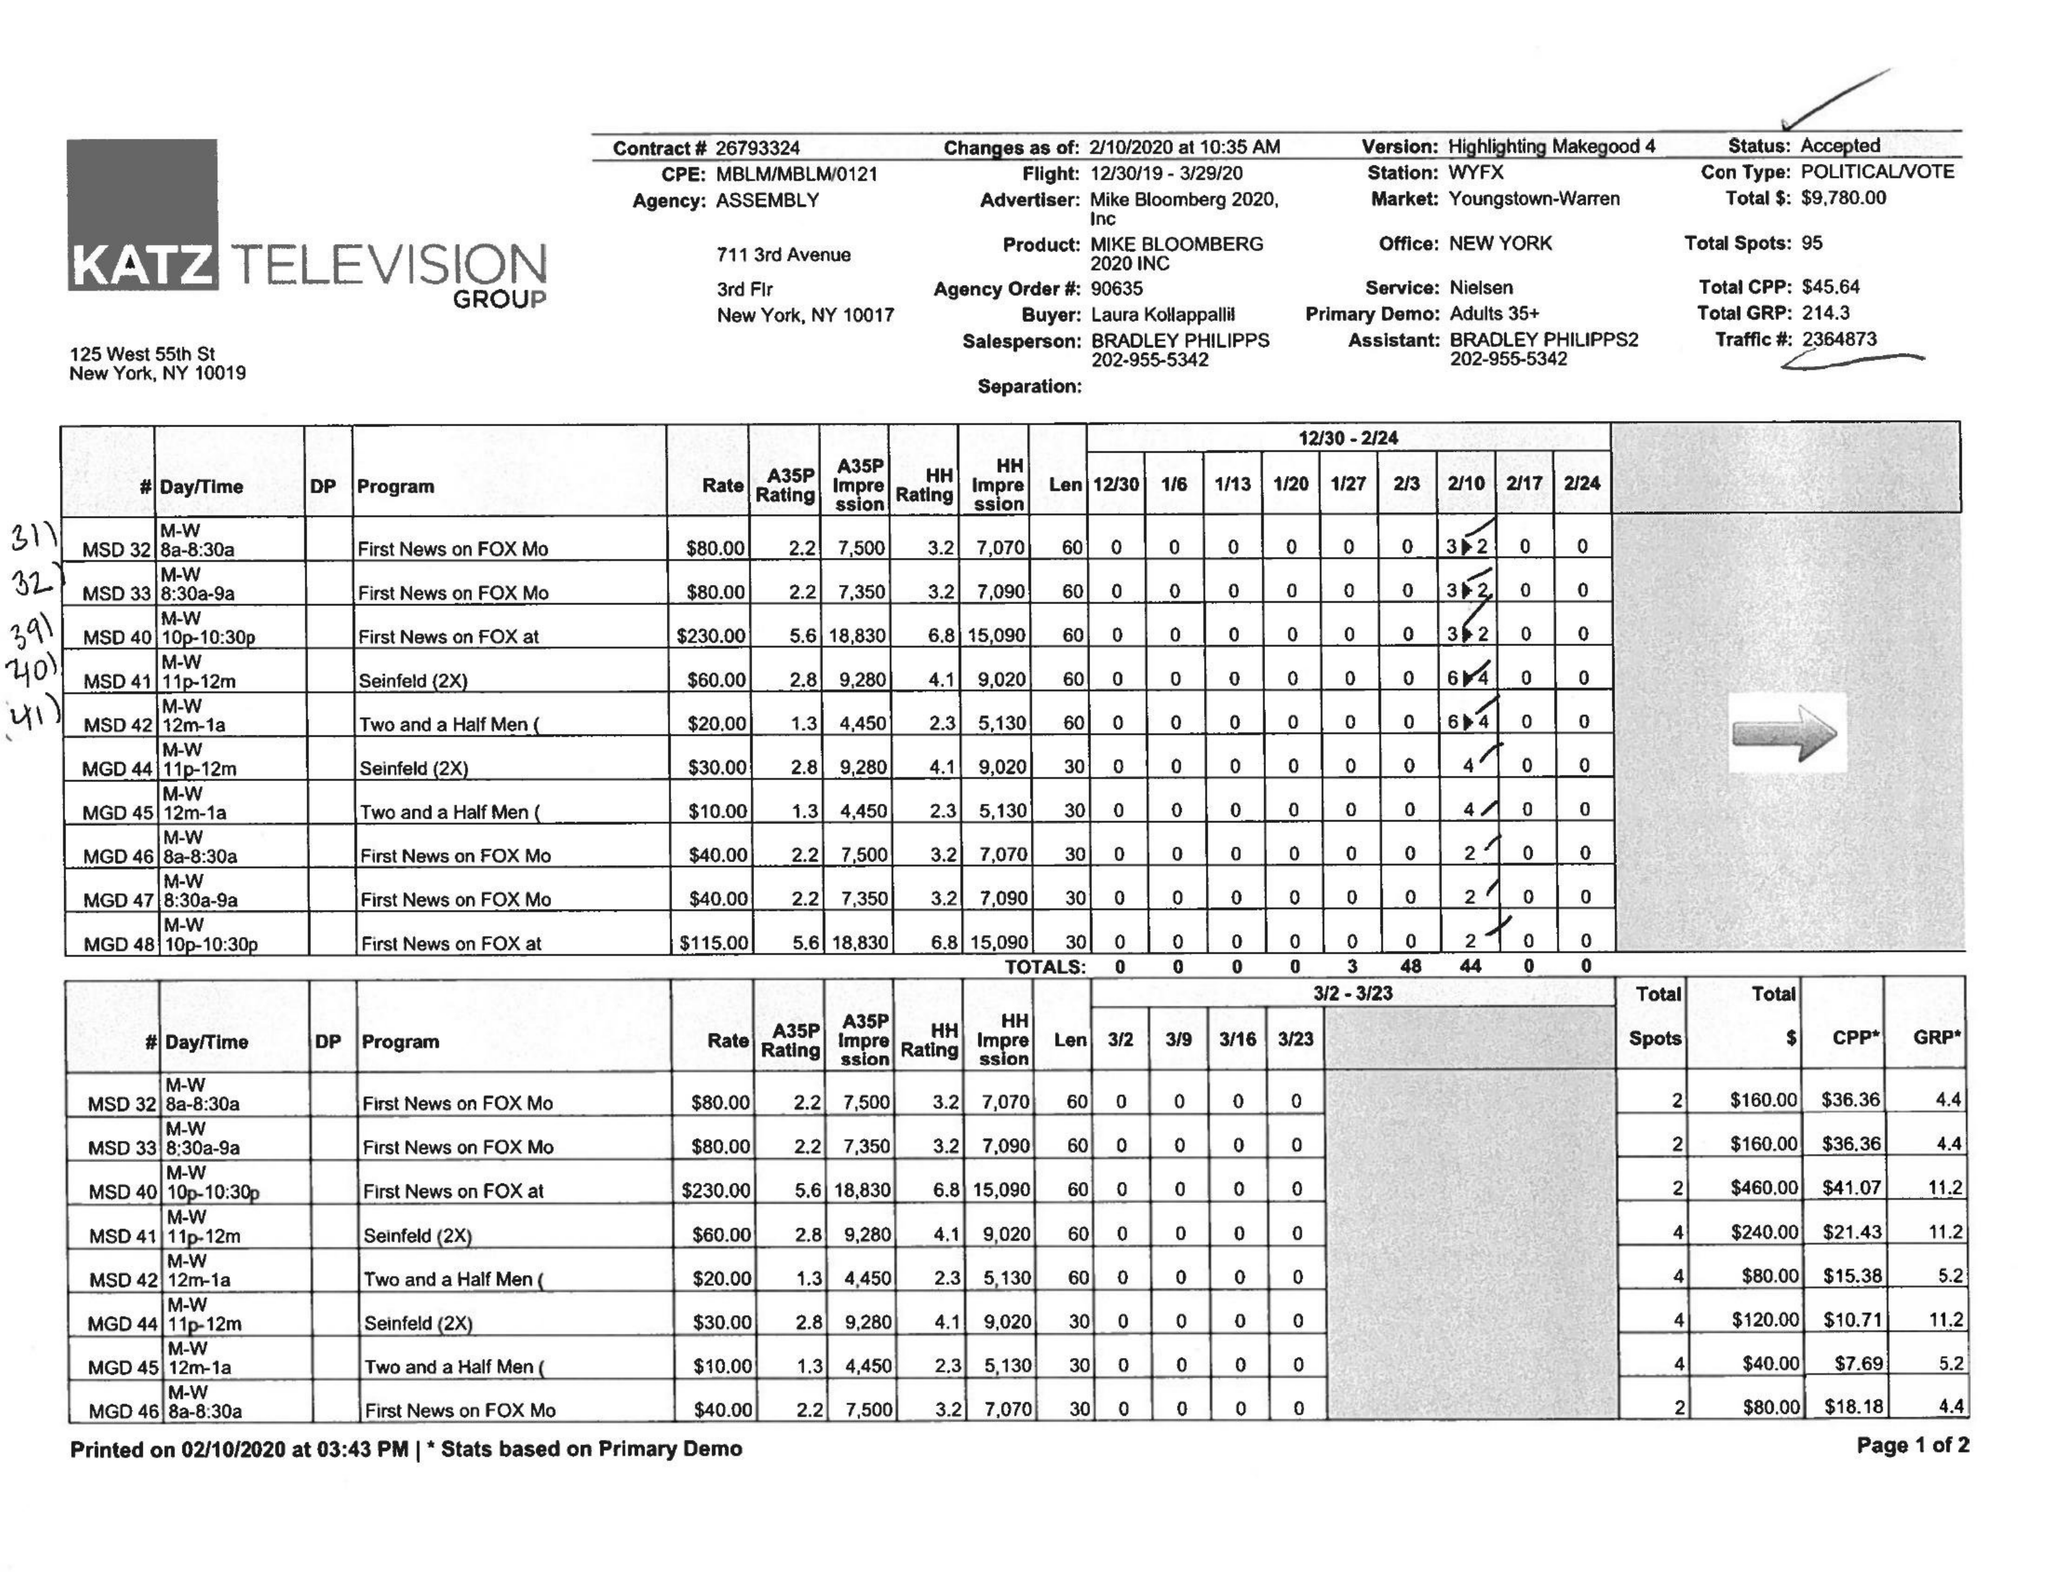What is the value for the contract_num?
Answer the question using a single word or phrase. 26793324 